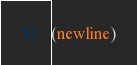<code> <loc_0><loc_0><loc_500><loc_500><_Scheme_>(newline)
</code> 